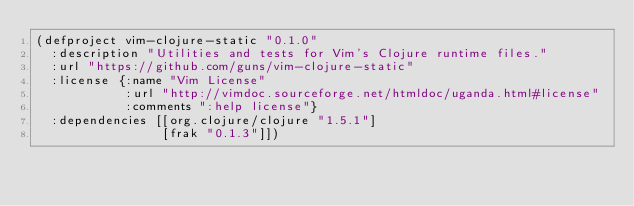<code> <loc_0><loc_0><loc_500><loc_500><_Clojure_>(defproject vim-clojure-static "0.1.0"
  :description "Utilities and tests for Vim's Clojure runtime files."
  :url "https://github.com/guns/vim-clojure-static"
  :license {:name "Vim License"
            :url "http://vimdoc.sourceforge.net/htmldoc/uganda.html#license"
            :comments ":help license"}
  :dependencies [[org.clojure/clojure "1.5.1"]
                 [frak "0.1.3"]])
</code> 